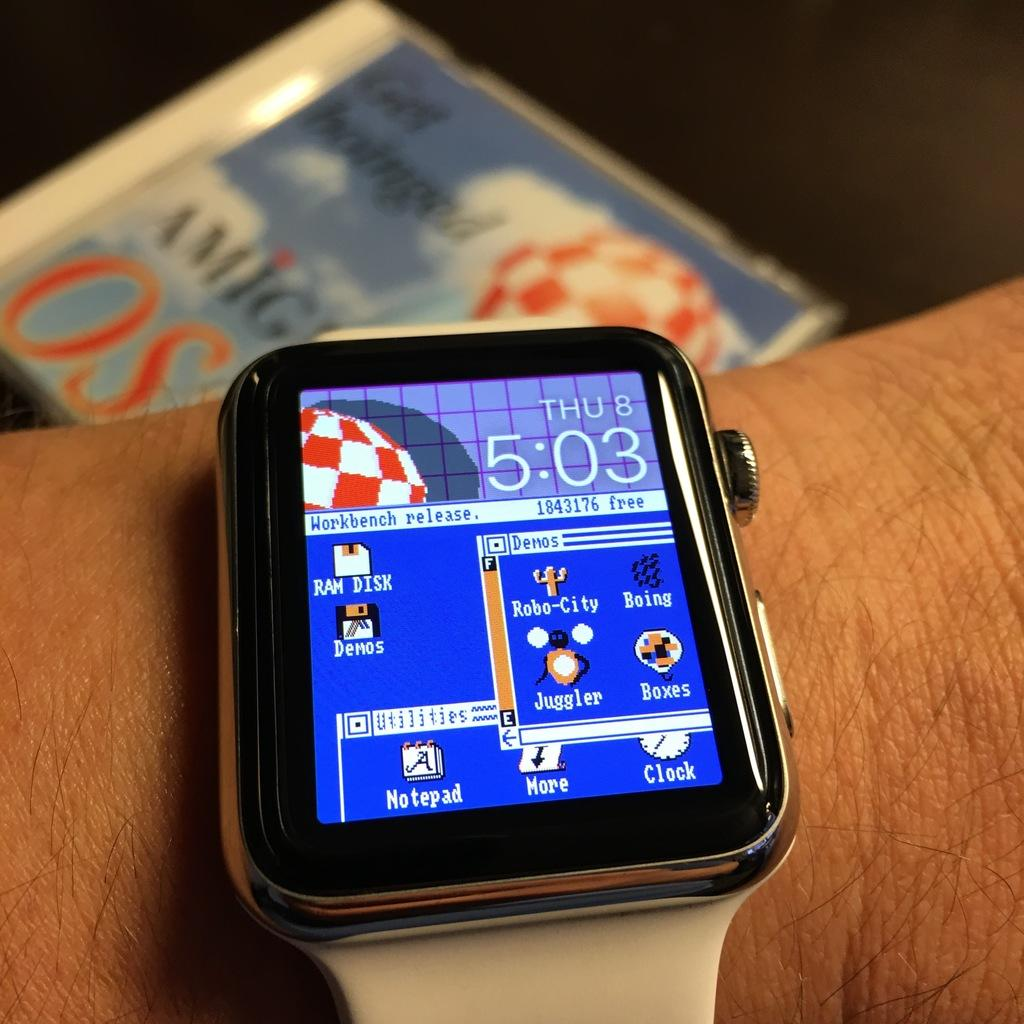Provide a one-sentence caption for the provided image. wrist with a smartwatch on it showing it is thursday the 8th at 5:03. 